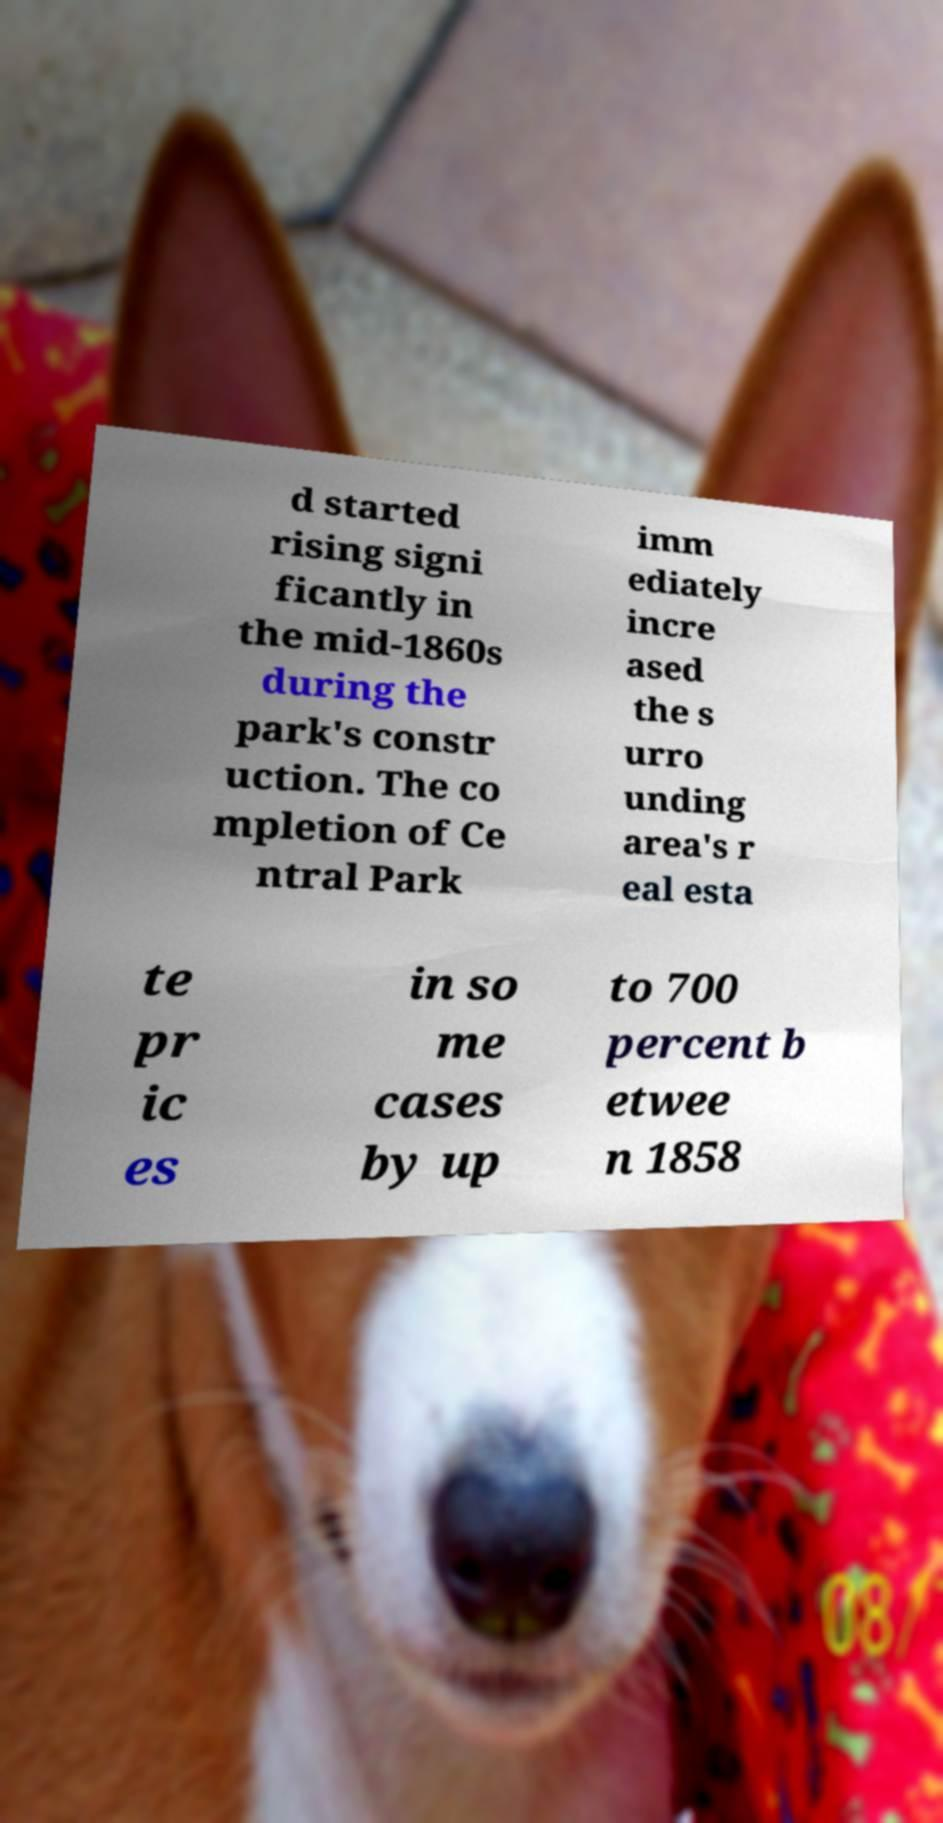Could you extract and type out the text from this image? d started rising signi ficantly in the mid-1860s during the park's constr uction. The co mpletion of Ce ntral Park imm ediately incre ased the s urro unding area's r eal esta te pr ic es in so me cases by up to 700 percent b etwee n 1858 